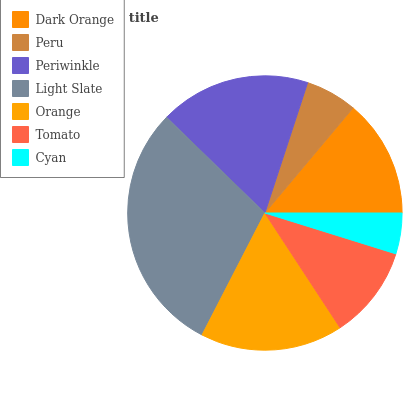Is Cyan the minimum?
Answer yes or no. Yes. Is Light Slate the maximum?
Answer yes or no. Yes. Is Peru the minimum?
Answer yes or no. No. Is Peru the maximum?
Answer yes or no. No. Is Dark Orange greater than Peru?
Answer yes or no. Yes. Is Peru less than Dark Orange?
Answer yes or no. Yes. Is Peru greater than Dark Orange?
Answer yes or no. No. Is Dark Orange less than Peru?
Answer yes or no. No. Is Dark Orange the high median?
Answer yes or no. Yes. Is Dark Orange the low median?
Answer yes or no. Yes. Is Cyan the high median?
Answer yes or no. No. Is Peru the low median?
Answer yes or no. No. 